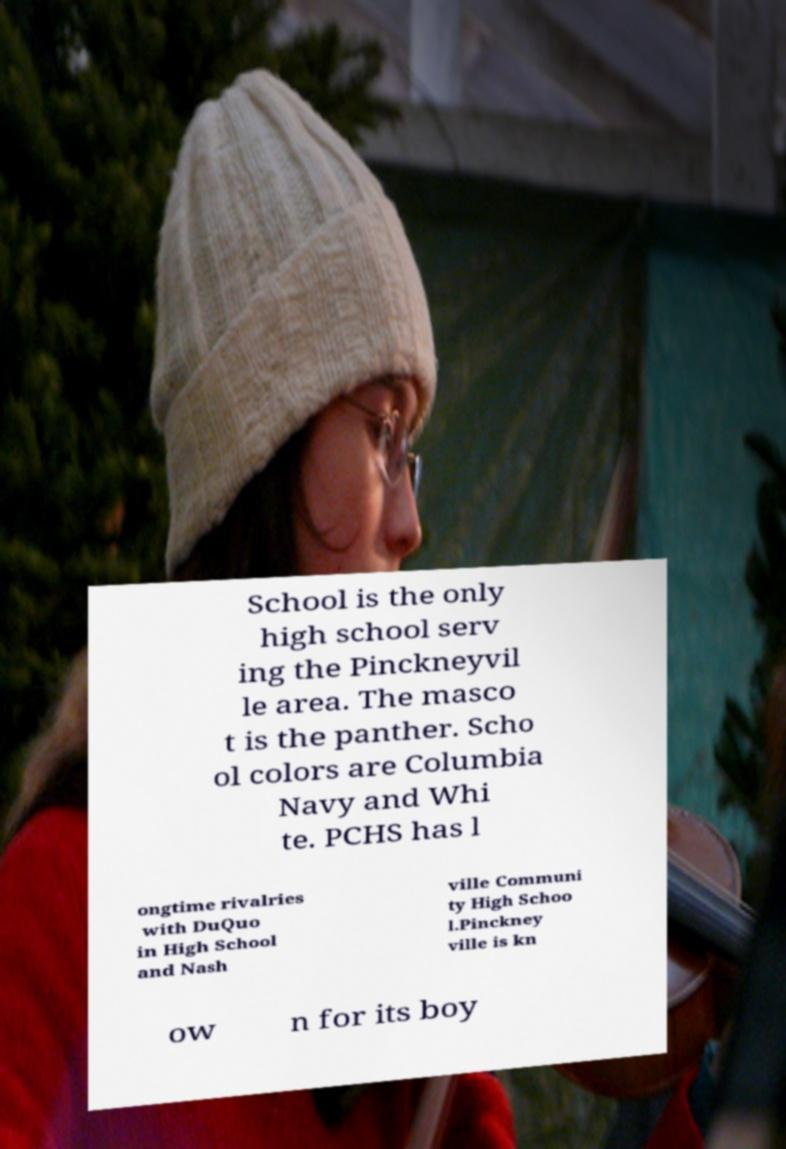There's text embedded in this image that I need extracted. Can you transcribe it verbatim? School is the only high school serv ing the Pinckneyvil le area. The masco t is the panther. Scho ol colors are Columbia Navy and Whi te. PCHS has l ongtime rivalries with DuQuo in High School and Nash ville Communi ty High Schoo l.Pinckney ville is kn ow n for its boy 